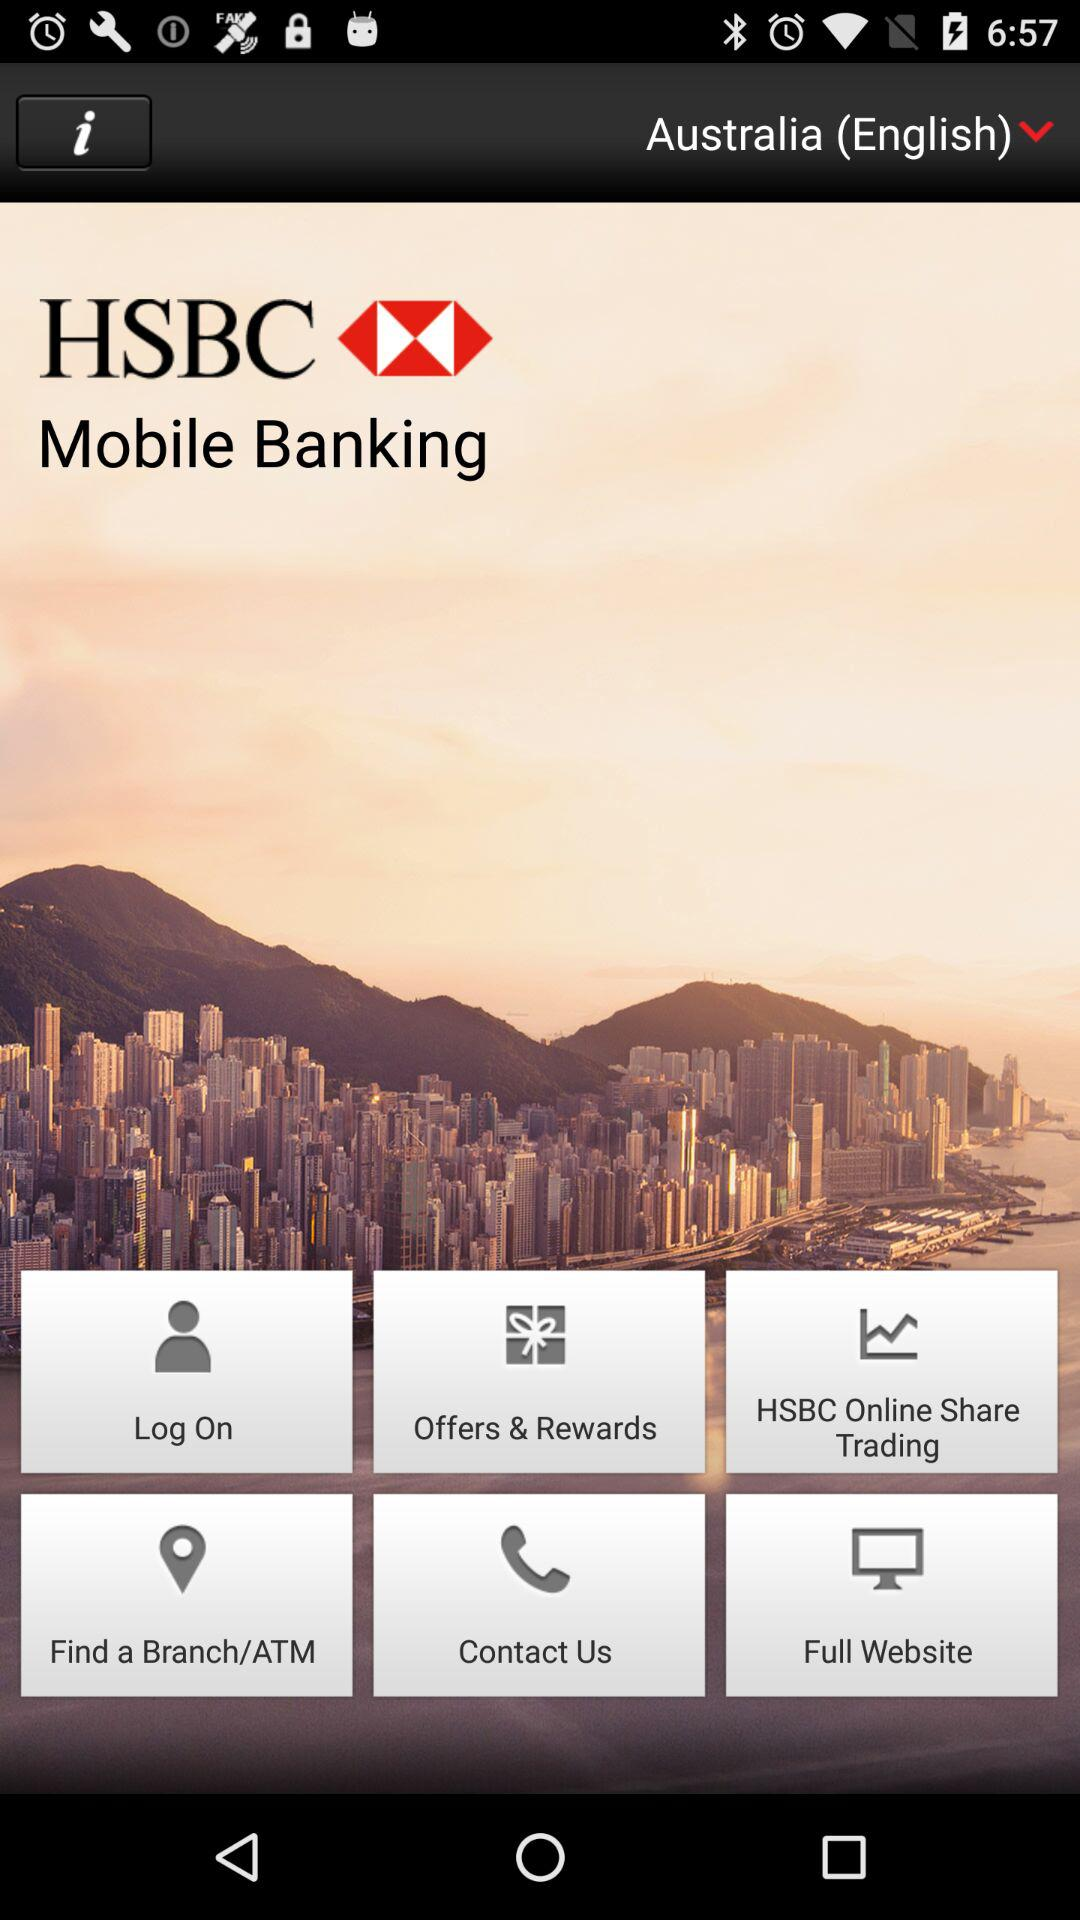What is the country name? The country name is Australia. 